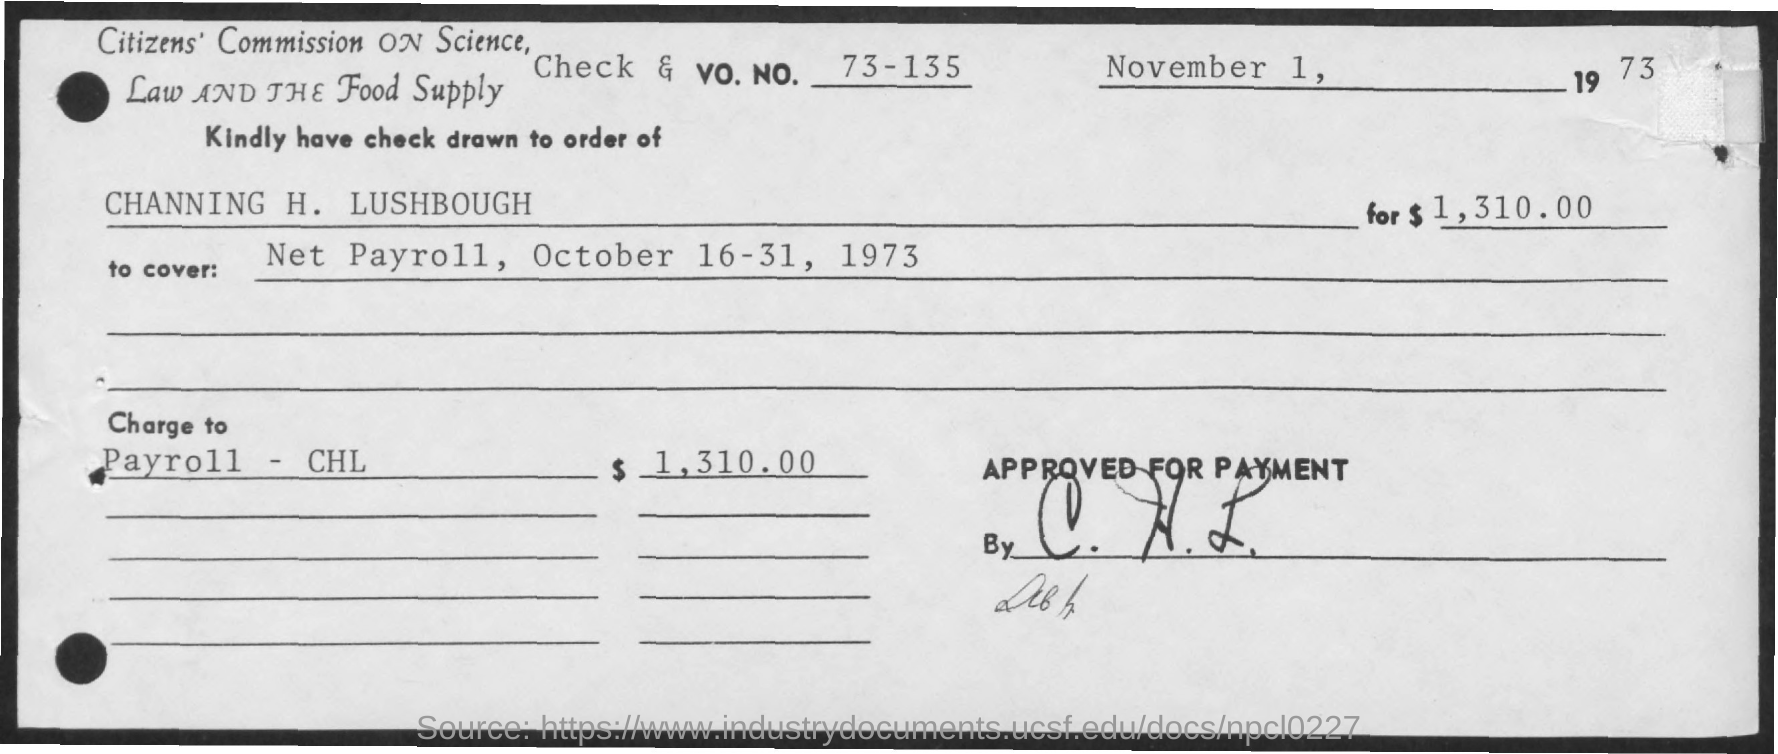Indicate a few pertinent items in this graphic. The amount is 1,310.00. 